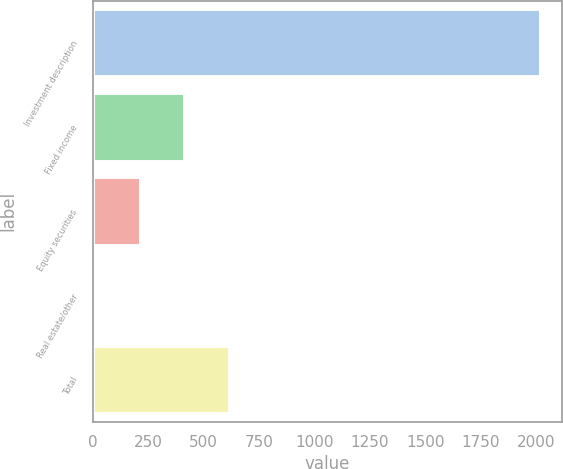<chart> <loc_0><loc_0><loc_500><loc_500><bar_chart><fcel>Investment description<fcel>Fixed income<fcel>Equity securities<fcel>Real estate/other<fcel>Total<nl><fcel>2016<fcel>413.76<fcel>213.48<fcel>13.2<fcel>614.04<nl></chart> 